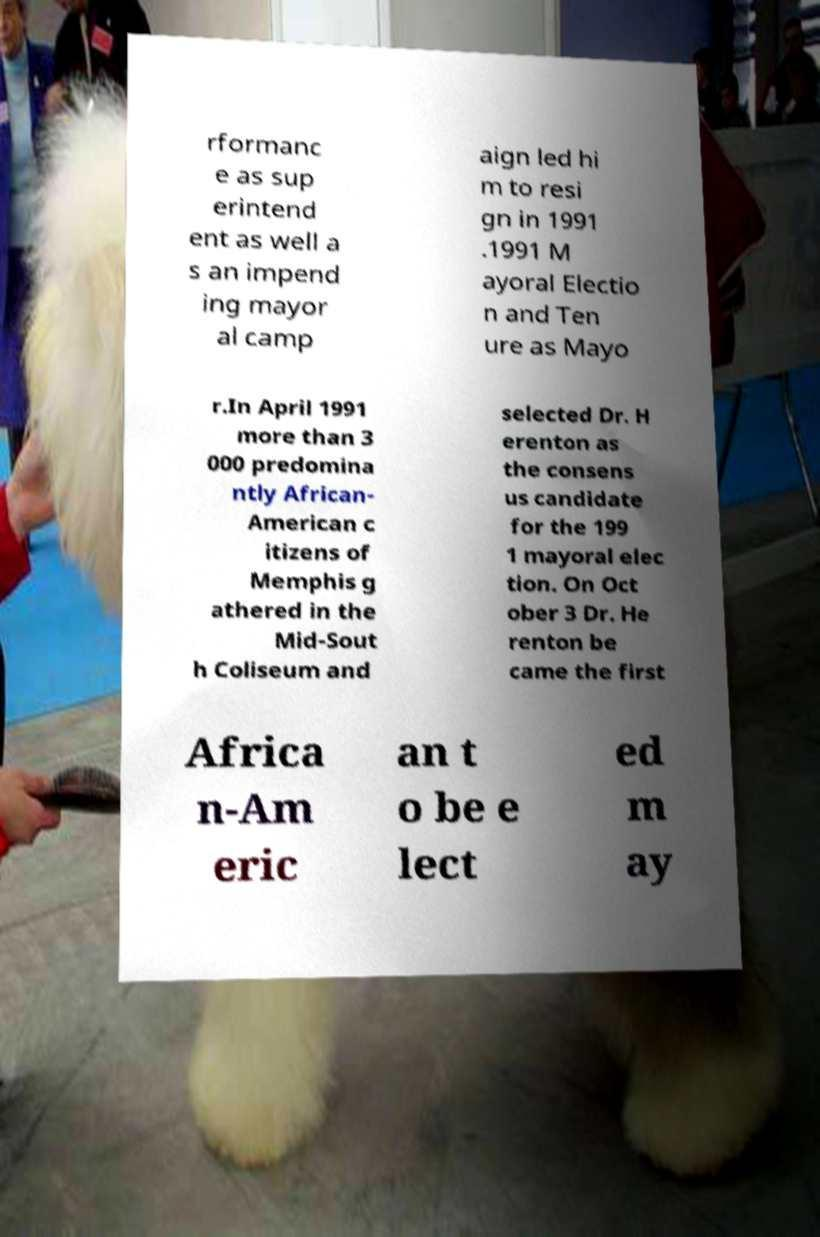Please read and relay the text visible in this image. What does it say? rformanc e as sup erintend ent as well a s an impend ing mayor al camp aign led hi m to resi gn in 1991 .1991 M ayoral Electio n and Ten ure as Mayo r.In April 1991 more than 3 000 predomina ntly African- American c itizens of Memphis g athered in the Mid-Sout h Coliseum and selected Dr. H erenton as the consens us candidate for the 199 1 mayoral elec tion. On Oct ober 3 Dr. He renton be came the first Africa n-Am eric an t o be e lect ed m ay 